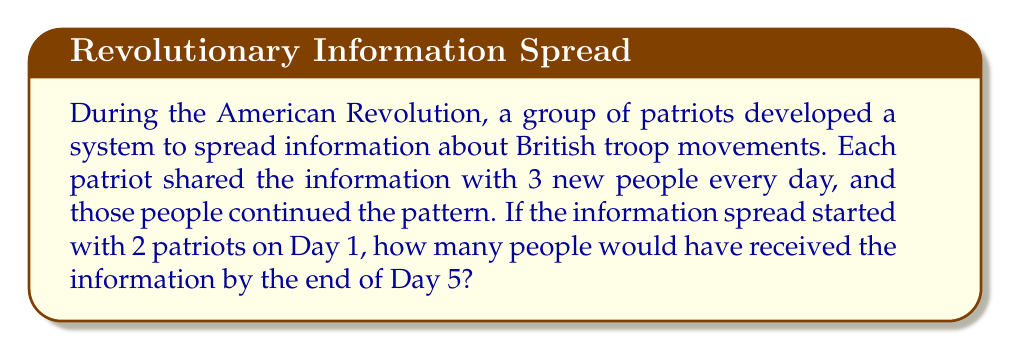What is the answer to this math problem? Let's approach this step-by-step:

1) We start with 2 patriots on Day 1.

2) Each day, the number of new people informed triples. This creates an exponential pattern.

3) Let's calculate the number of people informed each day:

   Day 1: $2$ (initial patriots)
   Day 2: $2 \times 3 = 6$ new people
   Day 3: $6 \times 3 = 18$ new people
   Day 4: $18 \times 3 = 54$ new people
   Day 5: $54 \times 3 = 162$ new people

4) To find the total number of people informed by the end of Day 5, we sum all these numbers:

   $$ \text{Total} = 2 + 6 + 18 + 54 + 162 $$

5) We can express this more concisely using exponents:

   $$ \text{Total} = 2 + 2 \times 3^1 + 2 \times 3^2 + 2 \times 3^3 + 2 \times 3^4 $$

6) This is a geometric series with first term $a=2$ and common ratio $r=3$. The sum of a geometric series is given by the formula:

   $$ S_n = \frac{a(1-r^n)}{1-r} $$

   Where $n$ is the number of terms (in this case, 5).

7) Plugging in our values:

   $$ S_5 = \frac{2(1-3^5)}{1-3} = \frac{2(1-243)}{-2} = \frac{2 \times 242}{2} = 242 $$

Therefore, by the end of Day 5, 242 people would have received the information.
Answer: 242 people 